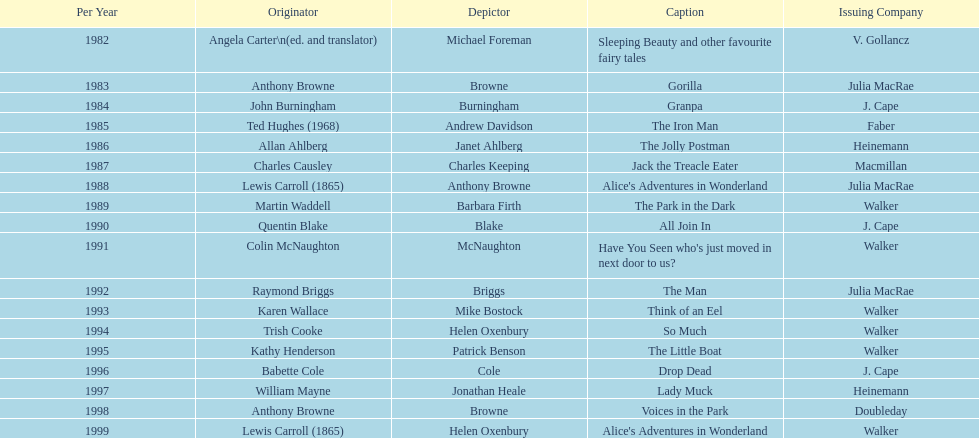How many titles had the same author listed as the illustrator? 7. 